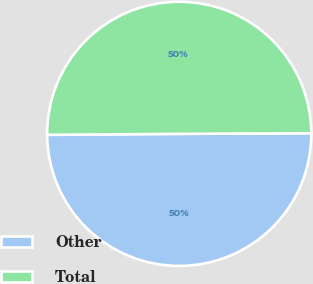Convert chart to OTSL. <chart><loc_0><loc_0><loc_500><loc_500><pie_chart><fcel>Other<fcel>Total<nl><fcel>49.95%<fcel>50.05%<nl></chart> 